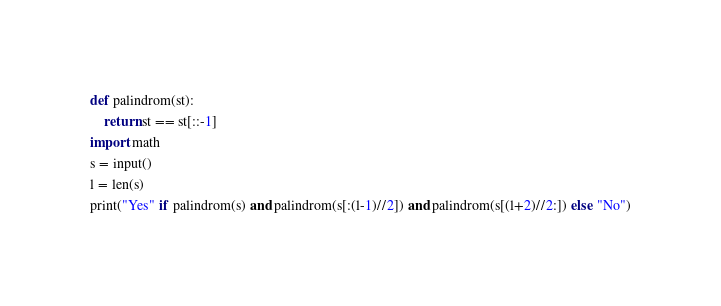Convert code to text. <code><loc_0><loc_0><loc_500><loc_500><_Python_>def palindrom(st):
    return st == st[::-1]
import math
s = input()
l = len(s)
print("Yes" if palindrom(s) and palindrom(s[:(l-1)//2]) and palindrom(s[(l+2)//2:]) else "No")</code> 